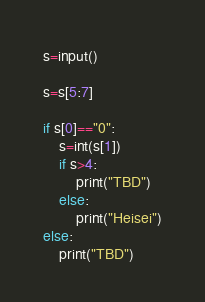<code> <loc_0><loc_0><loc_500><loc_500><_Python_>s=input()

s=s[5:7]

if s[0]=="0":
    s=int(s[1])
    if s>4:
        print("TBD")
    else:
        print("Heisei")
else:
    print("TBD")
</code> 